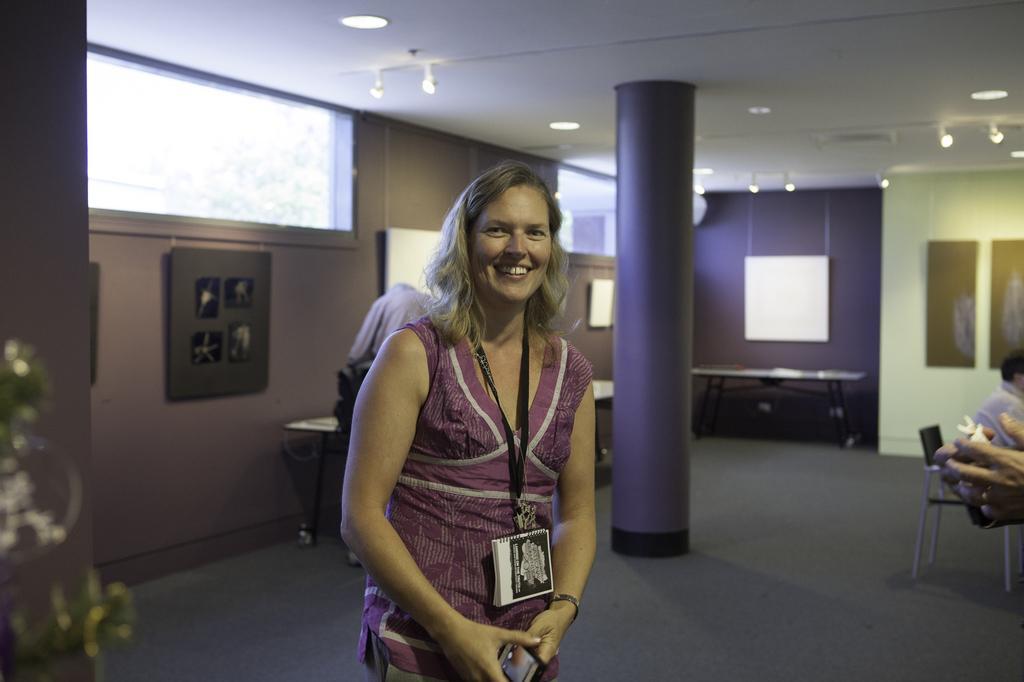In one or two sentences, can you explain what this image depicts? This picture is taken inside the room. In this image, in the middle, we can see a woman standing and holding a mobile in her hand. On the right side, we can also see a person sitting on the chair. On the right side, we can also see hand of a person holding some object. In the left corner, we can see some plants. In the background, we can see a person, table, pillar, window and few photo frames which are attached to a wall. At the top, we can see a roof with few lights. 